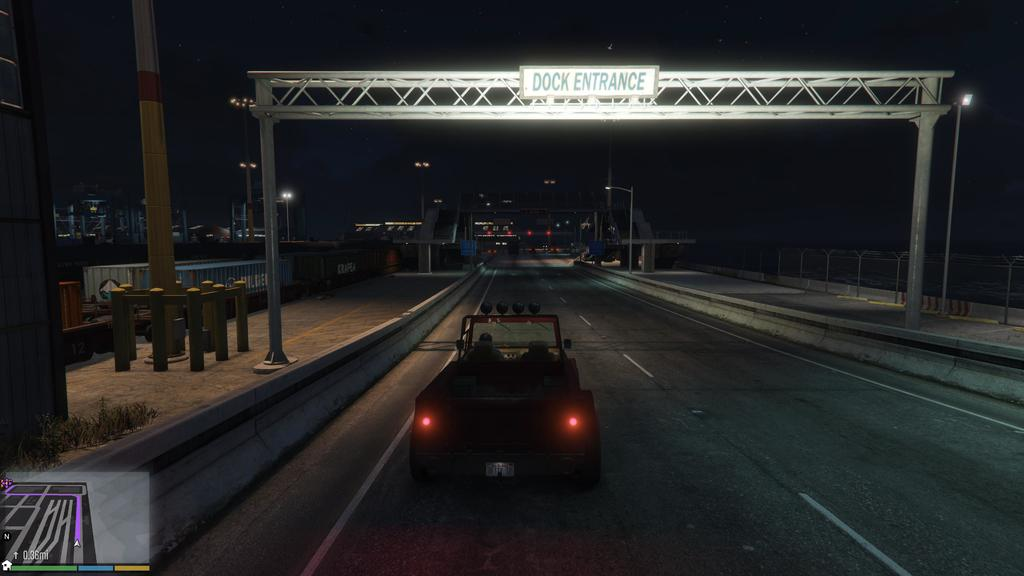What type of image is being depicted? The image appears to be a computer game. What is the main subject in the middle of the image? There is a vehicle in the middle of the image. What other features can be seen in the middle of the image? There are lights and an arch-like structure in the middle of the image. How many trucks are being held in the jail in the image? There is no jail or trucks present in the image. What type of magic is being performed by the vehicle in the image? There is no magic or indication of any magical abilities in the image; it is a computer game featuring a vehicle, lights, and an arch-like structure. 